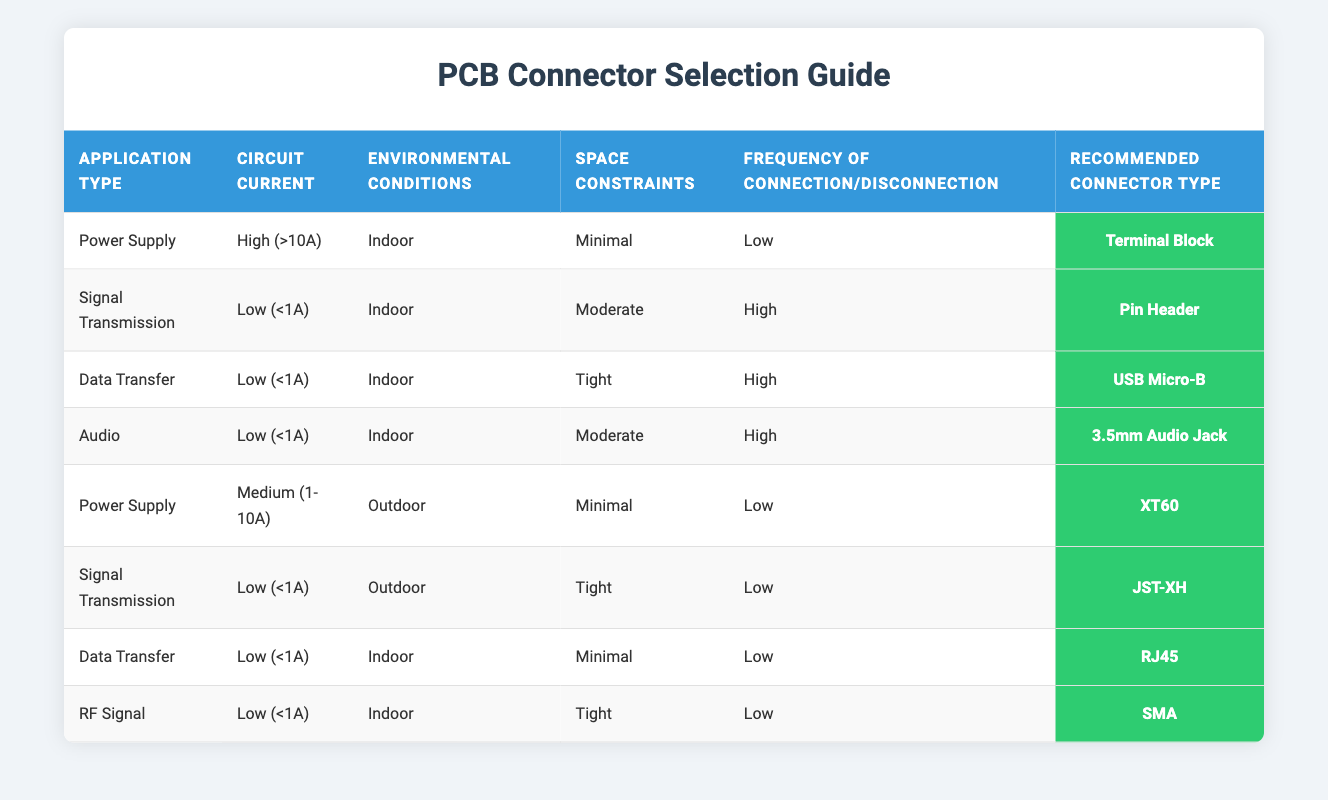What connector is recommended for a Low (<1A) Signal Transmission application? By looking at the table, I can see that for Signal Transmission with a Circuit Current of Low (<1A), the recommended connector type is Pin Header.
Answer: Pin Header What is the recommended connector type for a Power Supply application with Medium (1-10A) Circuit Current and Indoor Environmental Conditions? The table indicates that for the Power Supply application with Medium (1-10A) Circuit Current, the recommended connector type is XT60.
Answer: XT60 Is a 3.5mm Audio Jack suitable for High frequency of connection/disconnection? The table shows that while the 3.5mm Audio Jack is recommended, it is specifically for an application with a Low frequency of connection/disconnection, so it is not suitable.
Answer: No What connector is used for Data Transfer in tight spaces? According to the table, the recommended connector type for Data Transfer under Tight space constraints is USB Micro-B.
Answer: USB Micro-B How many connector types are recommended for Low (<1A) applications? By examining the table, there are four Low (<1A) connector options listed: Pin Header, USB Micro-B, 3.5mm Audio Jack, and RJ45. So, the total is four.
Answer: 4 Is it true that the recommended connector for Indoor Environmental Conditions and Low current is the same for Audio and Signal Transmission applications? Yes, looking at the table, both Audio and Signal Transmission applications have the same current requirements and environmental conditions, which leads to different recommended connector types. So, the statement is indeed true.
Answer: Yes What is the recommended connector type for an Outdoor Low (<1A) Signal Transmission application with Tight space constraints and Low frequency of connection/disconnection? The table specifies that for an Outdoor Signal Transmission application with the indicated conditions, the recommended connector is JST-XH.
Answer: JST-XH If I want to minimize space, what connector should I use for a Power Supply application indoors with High Circuit Current? The table directs you to use a Terminal Block when the conditions are High Circuit Current, Indoor, and Minimal Space Constraints for a Power Supply application.
Answer: Terminal Block 